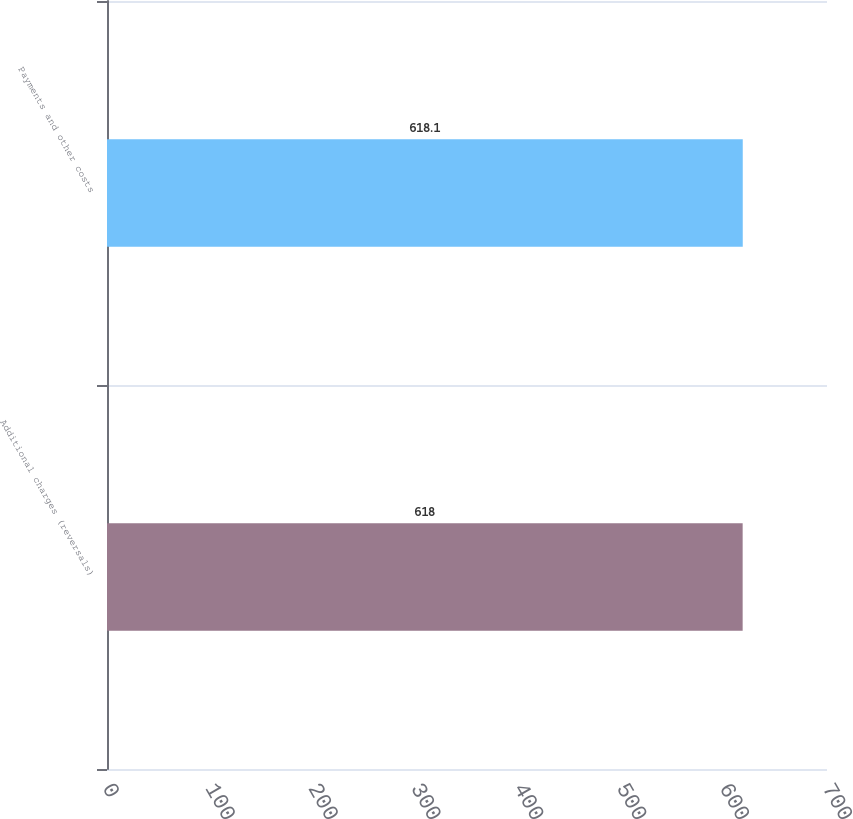Convert chart. <chart><loc_0><loc_0><loc_500><loc_500><bar_chart><fcel>Additional charges (reversals)<fcel>Payments and other costs<nl><fcel>618<fcel>618.1<nl></chart> 